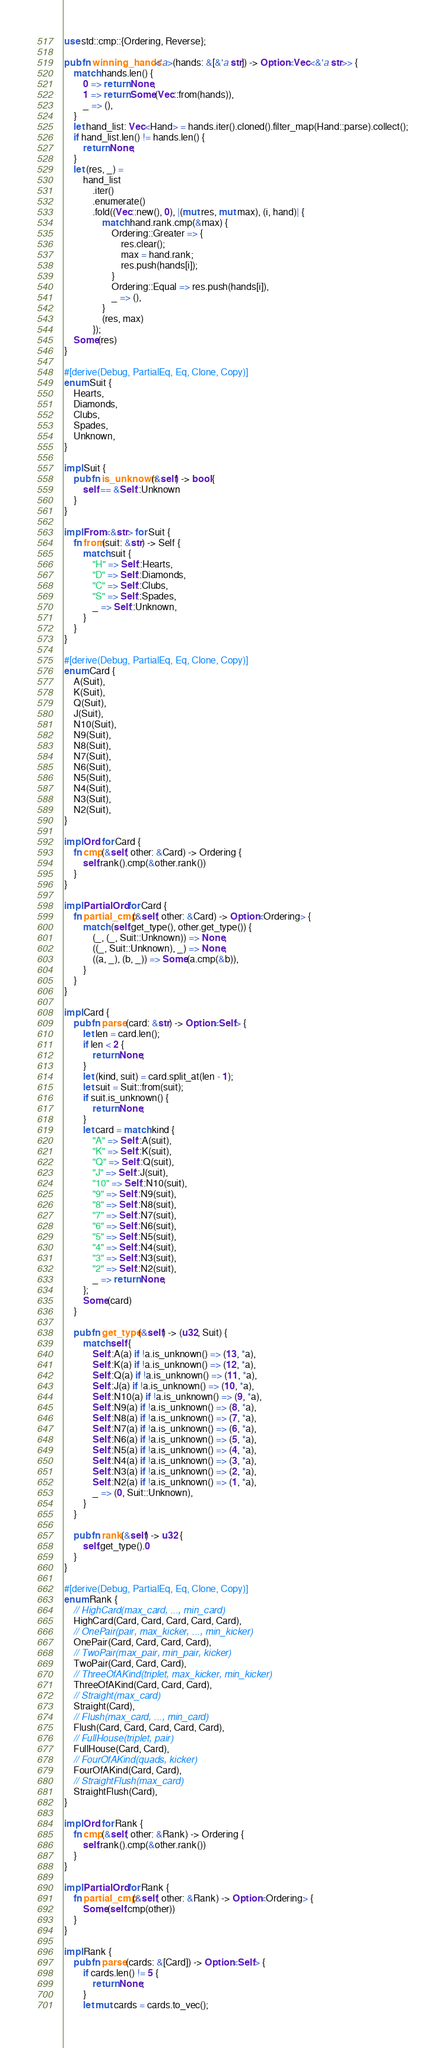Convert code to text. <code><loc_0><loc_0><loc_500><loc_500><_Rust_>use std::cmp::{Ordering, Reverse};

pub fn winning_hands<'a>(hands: &[&'a str]) -> Option<Vec<&'a str>> {
    match hands.len() {
        0 => return None,
        1 => return Some(Vec::from(hands)),
        _ => (),
    }
    let hand_list: Vec<Hand> = hands.iter().cloned().filter_map(Hand::parse).collect();
    if hand_list.len() != hands.len() {
        return None;
    }
    let (res, _) =
        hand_list
            .iter()
            .enumerate()
            .fold((Vec::new(), 0), |(mut res, mut max), (i, hand)| {
                match hand.rank.cmp(&max) {
                    Ordering::Greater => {
                        res.clear();
                        max = hand.rank;
                        res.push(hands[i]);
                    }
                    Ordering::Equal => res.push(hands[i]),
                    _ => (),
                }
                (res, max)
            });
    Some(res)
}

#[derive(Debug, PartialEq, Eq, Clone, Copy)]
enum Suit {
    Hearts,
    Diamonds,
    Clubs,
    Spades,
    Unknown,
}

impl Suit {
    pub fn is_unknown(&self) -> bool {
        self == &Self::Unknown
    }
}

impl From<&str> for Suit {
    fn from(suit: &str) -> Self {
        match suit {
            "H" => Self::Hearts,
            "D" => Self::Diamonds,
            "C" => Self::Clubs,
            "S" => Self::Spades,
            _ => Self::Unknown,
        }
    }
}

#[derive(Debug, PartialEq, Eq, Clone, Copy)]
enum Card {
    A(Suit),
    K(Suit),
    Q(Suit),
    J(Suit),
    N10(Suit),
    N9(Suit),
    N8(Suit),
    N7(Suit),
    N6(Suit),
    N5(Suit),
    N4(Suit),
    N3(Suit),
    N2(Suit),
}

impl Ord for Card {
    fn cmp(&self, other: &Card) -> Ordering {
        self.rank().cmp(&other.rank())
    }
}

impl PartialOrd for Card {
    fn partial_cmp(&self, other: &Card) -> Option<Ordering> {
        match (self.get_type(), other.get_type()) {
            (_, (_, Suit::Unknown)) => None,
            ((_, Suit::Unknown), _) => None,
            ((a, _), (b, _)) => Some(a.cmp(&b)),
        }
    }
}

impl Card {
    pub fn parse(card: &str) -> Option<Self> {
        let len = card.len();
        if len < 2 {
            return None;
        }
        let (kind, suit) = card.split_at(len - 1);
        let suit = Suit::from(suit);
        if suit.is_unknown() {
            return None;
        }
        let card = match kind {
            "A" => Self::A(suit),
            "K" => Self::K(suit),
            "Q" => Self::Q(suit),
            "J" => Self::J(suit),
            "10" => Self::N10(suit),
            "9" => Self::N9(suit),
            "8" => Self::N8(suit),
            "7" => Self::N7(suit),
            "6" => Self::N6(suit),
            "5" => Self::N5(suit),
            "4" => Self::N4(suit),
            "3" => Self::N3(suit),
            "2" => Self::N2(suit),
            _ => return None,
        };
        Some(card)
    }

    pub fn get_type(&self) -> (u32, Suit) {
        match self {
            Self::A(a) if !a.is_unknown() => (13, *a),
            Self::K(a) if !a.is_unknown() => (12, *a),
            Self::Q(a) if !a.is_unknown() => (11, *a),
            Self::J(a) if !a.is_unknown() => (10, *a),
            Self::N10(a) if !a.is_unknown() => (9, *a),
            Self::N9(a) if !a.is_unknown() => (8, *a),
            Self::N8(a) if !a.is_unknown() => (7, *a),
            Self::N7(a) if !a.is_unknown() => (6, *a),
            Self::N6(a) if !a.is_unknown() => (5, *a),
            Self::N5(a) if !a.is_unknown() => (4, *a),
            Self::N4(a) if !a.is_unknown() => (3, *a),
            Self::N3(a) if !a.is_unknown() => (2, *a),
            Self::N2(a) if !a.is_unknown() => (1, *a),
            _ => (0, Suit::Unknown),
        }
    }

    pub fn rank(&self) -> u32 {
        self.get_type().0
    }
}

#[derive(Debug, PartialEq, Eq, Clone, Copy)]
enum Rank {
    // HighCard(max_card, ..., min_card)
    HighCard(Card, Card, Card, Card, Card),
    // OnePair(pair, max_kicker, ..., min_kicker)
    OnePair(Card, Card, Card, Card),
    // TwoPair(max_pair, min_pair, kicker)
    TwoPair(Card, Card, Card),
    // ThreeOfAKind(triplet, max_kicker, min_kicker)
    ThreeOfAKind(Card, Card, Card),
    // Straight(max_card)
    Straight(Card),
    // Flush(max_card, ..., min_card)
    Flush(Card, Card, Card, Card, Card),
    // FullHouse(triplet, pair)
    FullHouse(Card, Card),
    // FourOfAKind(quads, kicker)
    FourOfAKind(Card, Card),
    // StraightFlush(max_card)
    StraightFlush(Card),
}

impl Ord for Rank {
    fn cmp(&self, other: &Rank) -> Ordering {
        self.rank().cmp(&other.rank())
    }
}

impl PartialOrd for Rank {
    fn partial_cmp(&self, other: &Rank) -> Option<Ordering> {
        Some(self.cmp(other))
    }
}

impl Rank {
    pub fn parse(cards: &[Card]) -> Option<Self> {
        if cards.len() != 5 {
            return None;
        }
        let mut cards = cards.to_vec();</code> 